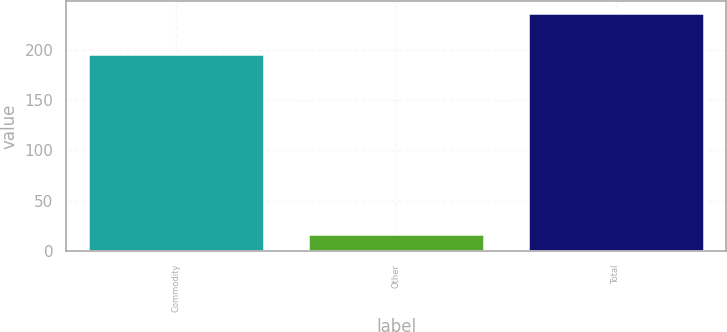Convert chart to OTSL. <chart><loc_0><loc_0><loc_500><loc_500><bar_chart><fcel>Commodity<fcel>Other<fcel>Total<nl><fcel>196<fcel>17<fcel>236<nl></chart> 